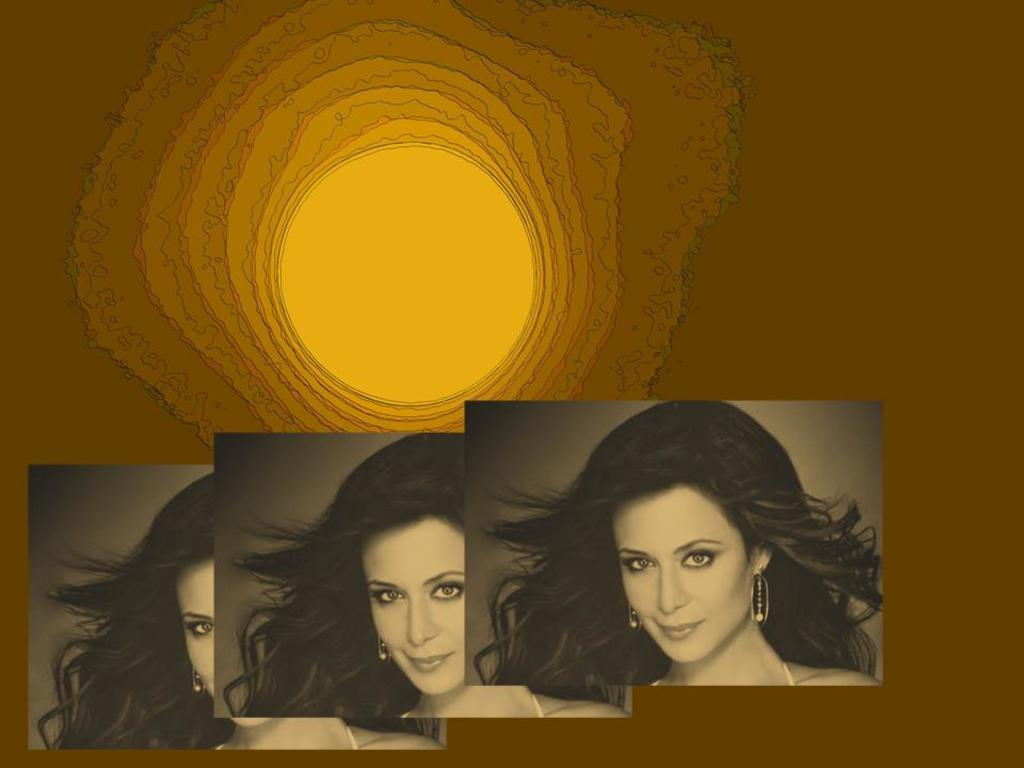What is depicted in the images in the picture? There are pictures of a person in the image. What color is the background of the image? The background color is yellow. What type of can is shown in the image? There is no can present in the image; it only contains pictures of a person with a yellow background. 